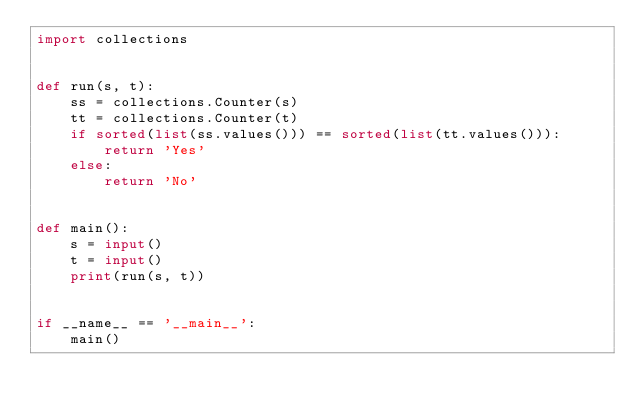<code> <loc_0><loc_0><loc_500><loc_500><_Python_>import collections


def run(s, t):
    ss = collections.Counter(s)
    tt = collections.Counter(t)
    if sorted(list(ss.values())) == sorted(list(tt.values())):
        return 'Yes'
    else:
        return 'No'


def main():
    s = input()
    t = input()
    print(run(s, t))


if __name__ == '__main__':
    main()
</code> 